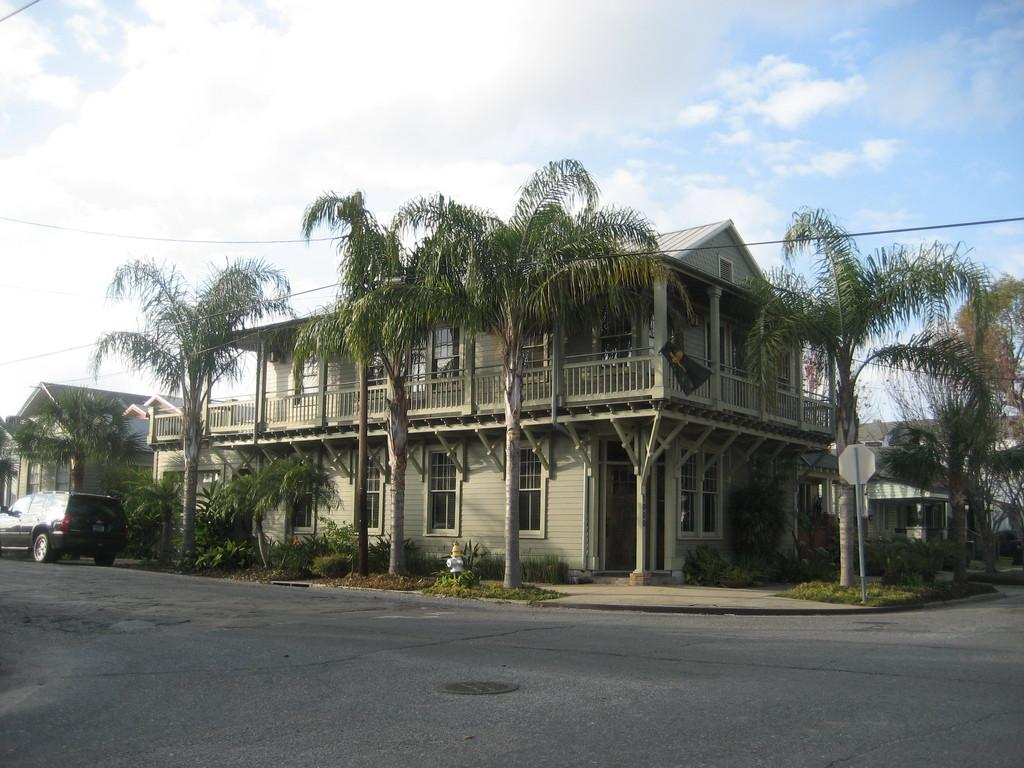What is on the road in the image? There is a vehicle on the road in the image. What object can be seen near the road? There is a hydrant in the image. What type of vegetation is present in the image? There are trees in the image. What type of structures can be seen in the image? There are houses with windows in the image. What is attached to a pole in the image? There is a board attached to a pole in the image. What type of infrastructure is visible in the image? There are wires in the image. What can be seen in the background of the image? The sky with clouds is visible in the background of the image. How many pigs are sitting on the loaf in the image? There are no pigs or loaves present in the image. What type of behavior is exhibited by the people in the image? There are no people present in the image, so their behavior cannot be observed. 